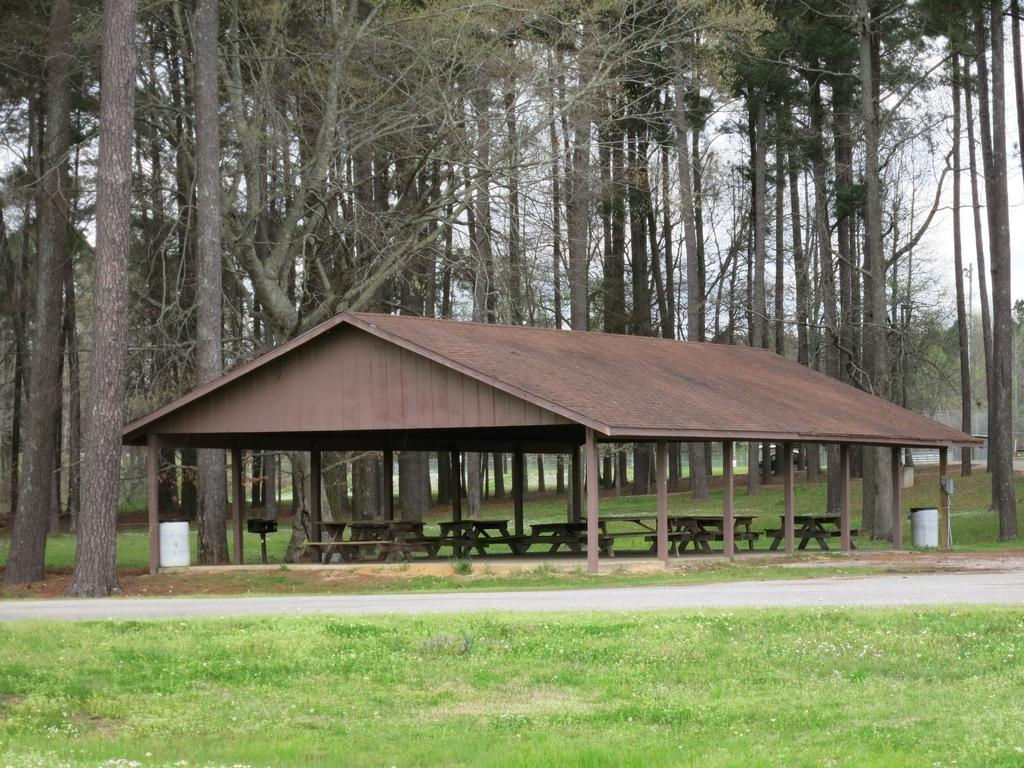What type of vegetation can be seen in the image? There are trees in the image. What structure is present in the image? There is a pole and a shed in the image. What type of furniture is visible in the image? There are tables and benches in the image. What color objects can be seen in the image? There are white color objects in the image. What type of ground surface is visible in the image? There is grass visible in the image. What is the color of the sky in the image? The sky is white in color. Can you tell me how many forks are depicted on the benches in the image? There are no forks present on the benches in the image. Is there a judge sitting on one of the tables in the image? There is no judge present in the image. 